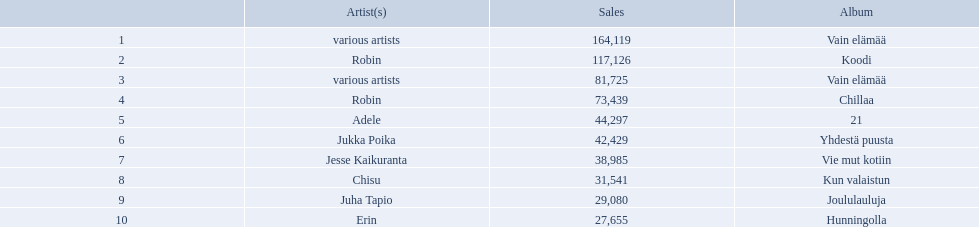Which artists' albums reached number one in finland during 2012? 164,119, 117,126, 81,725, 73,439, 44,297, 42,429, 38,985, 31,541, 29,080, 27,655. What were the sales figures of these albums? Various artists, robin, various artists, robin, adele, jukka poika, jesse kaikuranta, chisu, juha tapio, erin. And did adele or chisu have more sales during this period? Adele. 